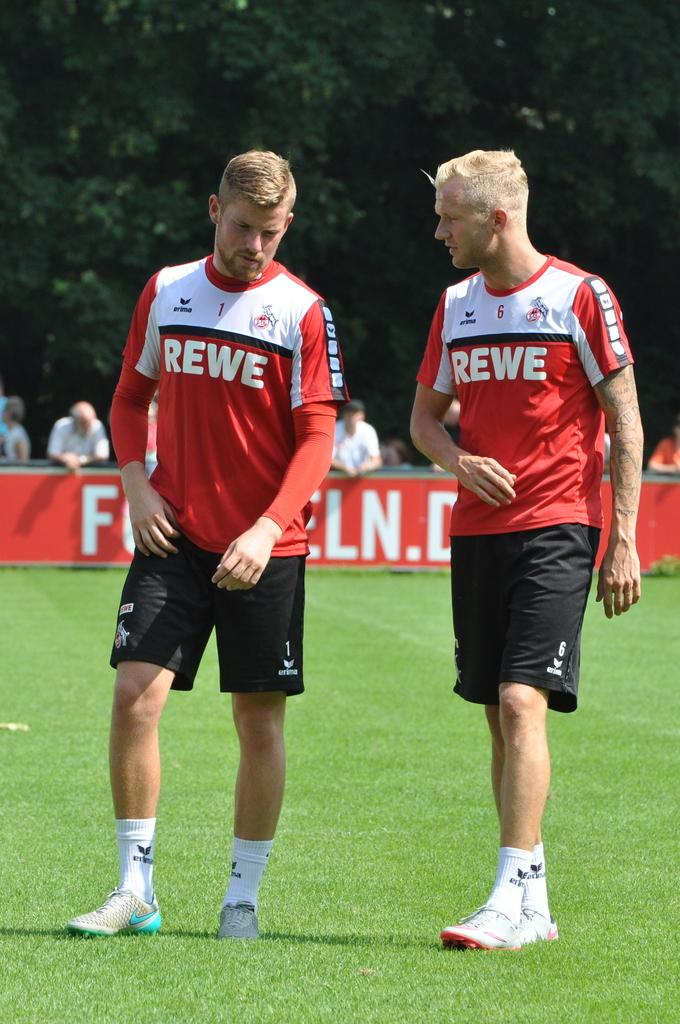<image>
Create a compact narrative representing the image presented. Two teammates wearing REWE jerseys walks across a field. 